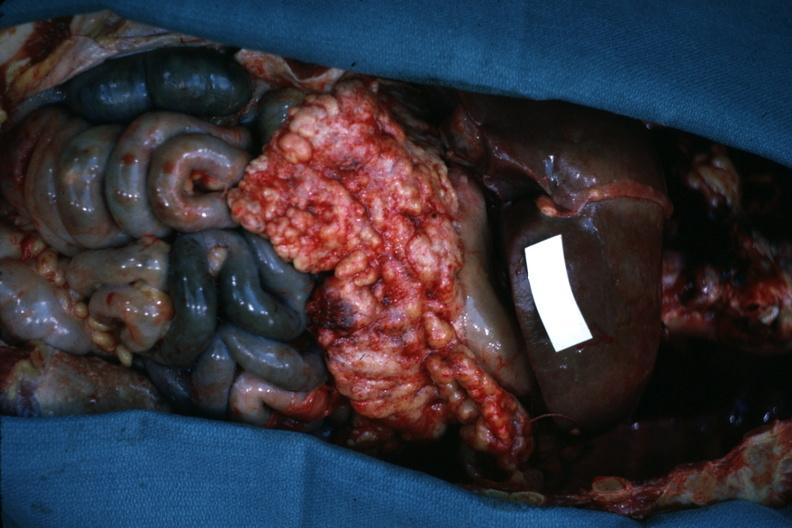what is present?
Answer the question using a single word or phrase. Metastatic carcinoma 